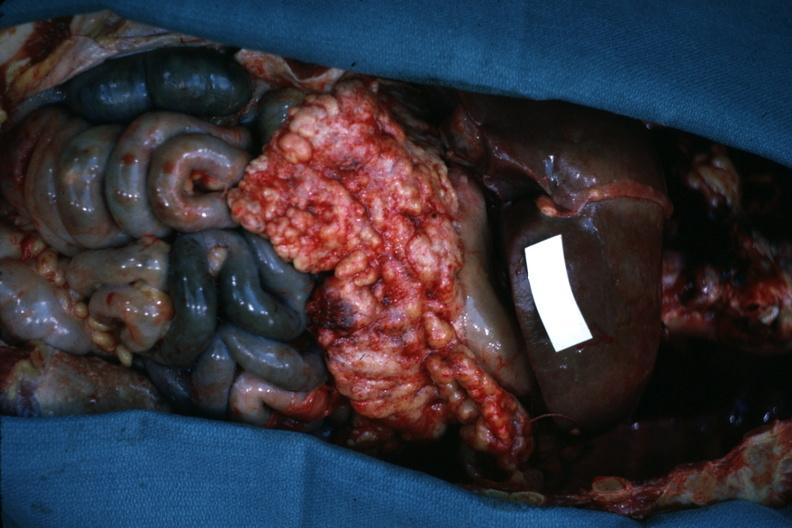what is present?
Answer the question using a single word or phrase. Metastatic carcinoma 